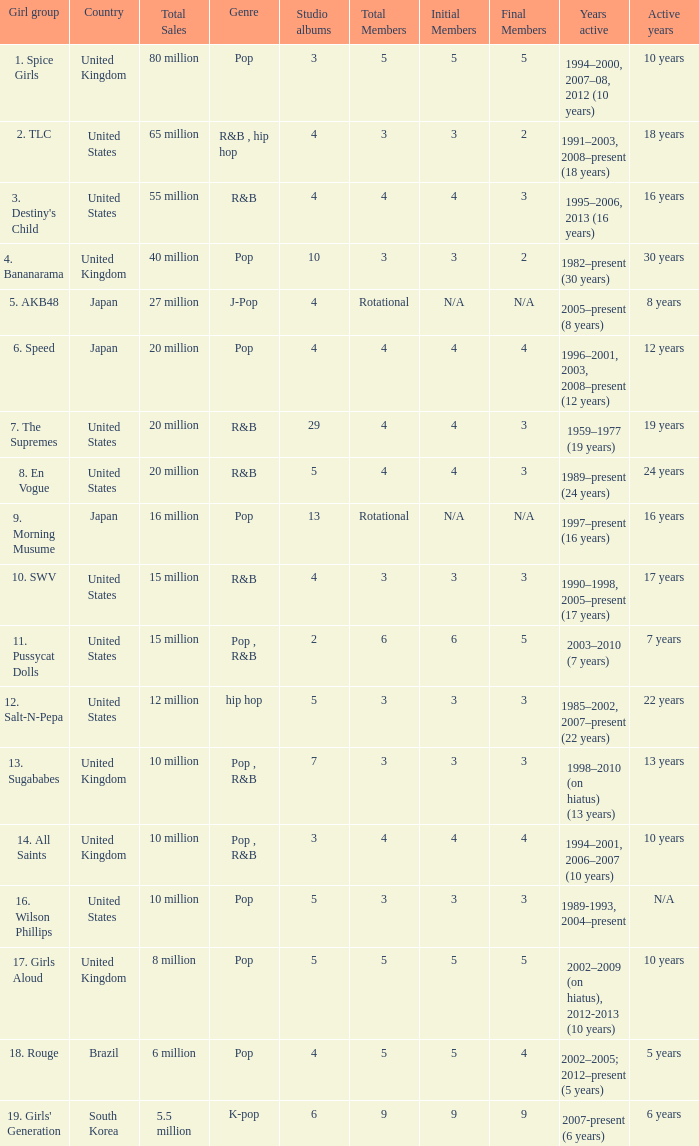Which ensemble produced 29 studio records? 7. The Supremes. 